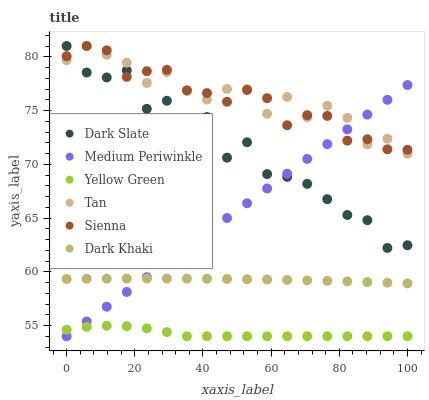Does Yellow Green have the minimum area under the curve?
Answer yes or no. Yes. Does Tan have the maximum area under the curve?
Answer yes or no. Yes. Does Medium Periwinkle have the minimum area under the curve?
Answer yes or no. No. Does Medium Periwinkle have the maximum area under the curve?
Answer yes or no. No. Is Medium Periwinkle the smoothest?
Answer yes or no. Yes. Is Dark Slate the roughest?
Answer yes or no. Yes. Is Yellow Green the smoothest?
Answer yes or no. No. Is Yellow Green the roughest?
Answer yes or no. No. Does Yellow Green have the lowest value?
Answer yes or no. Yes. Does Sienna have the lowest value?
Answer yes or no. No. Does Tan have the highest value?
Answer yes or no. Yes. Does Medium Periwinkle have the highest value?
Answer yes or no. No. Is Dark Khaki less than Tan?
Answer yes or no. Yes. Is Sienna greater than Dark Khaki?
Answer yes or no. Yes. Does Sienna intersect Dark Slate?
Answer yes or no. Yes. Is Sienna less than Dark Slate?
Answer yes or no. No. Is Sienna greater than Dark Slate?
Answer yes or no. No. Does Dark Khaki intersect Tan?
Answer yes or no. No. 